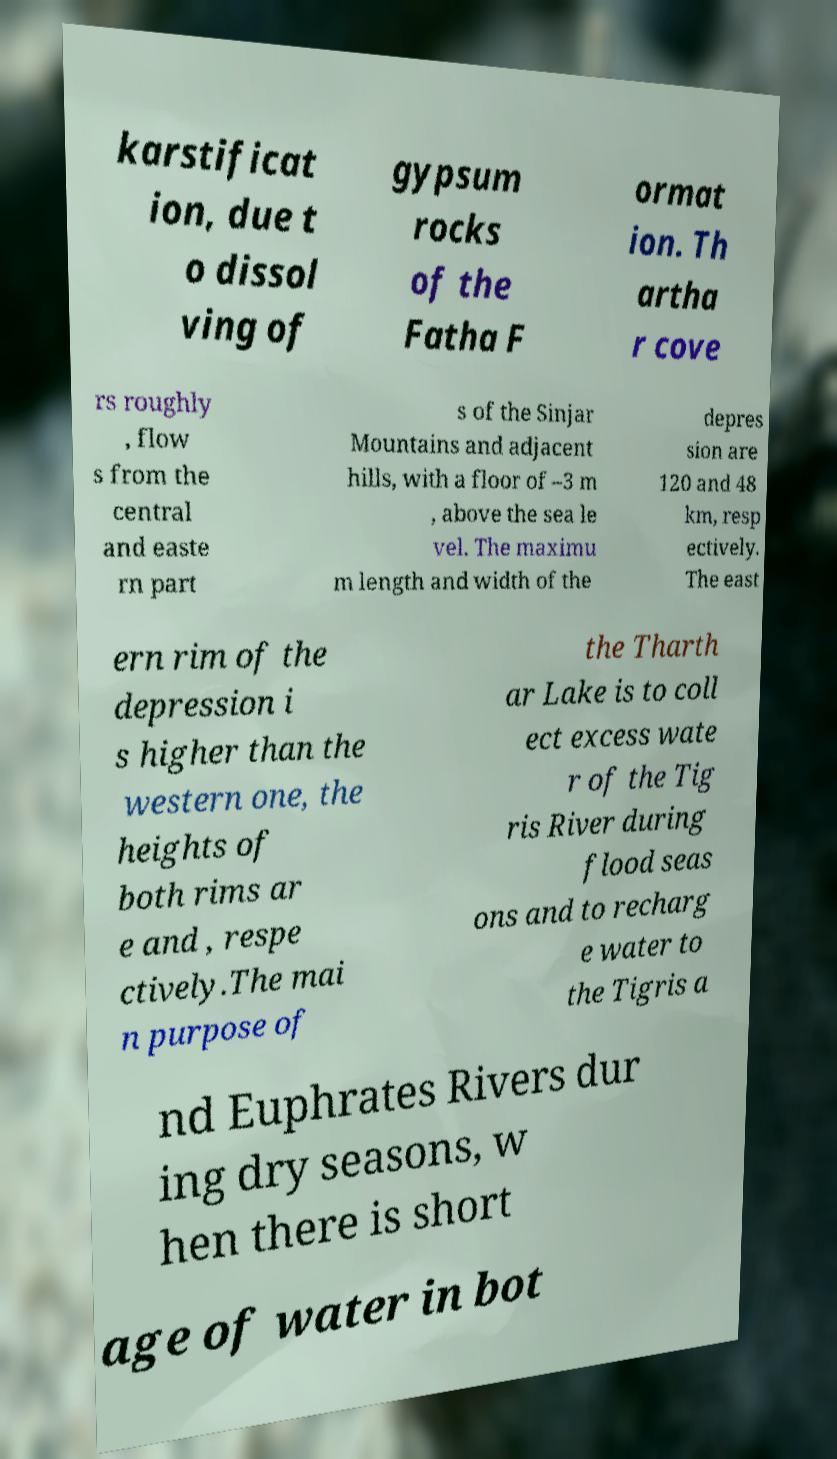Can you read and provide the text displayed in the image?This photo seems to have some interesting text. Can you extract and type it out for me? karstificat ion, due t o dissol ving of gypsum rocks of the Fatha F ormat ion. Th artha r cove rs roughly , flow s from the central and easte rn part s of the Sinjar Mountains and adjacent hills, with a floor of –3 m , above the sea le vel. The maximu m length and width of the depres sion are 120 and 48 km, resp ectively. The east ern rim of the depression i s higher than the western one, the heights of both rims ar e and , respe ctively.The mai n purpose of the Tharth ar Lake is to coll ect excess wate r of the Tig ris River during flood seas ons and to recharg e water to the Tigris a nd Euphrates Rivers dur ing dry seasons, w hen there is short age of water in bot 